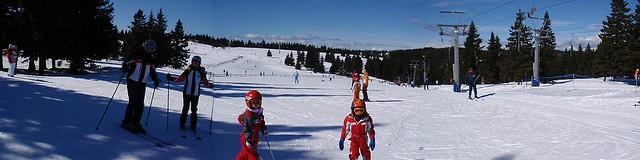What are the metal towers used for?

Choices:
A) cell phones
B) transportation
C) climbing
D) gaming transportation 